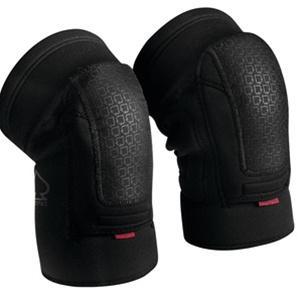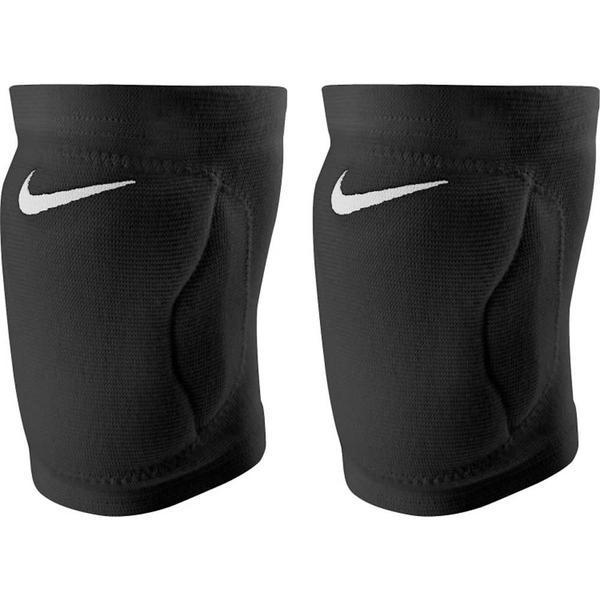The first image is the image on the left, the second image is the image on the right. Examine the images to the left and right. Is the description "Images each show one knee pad, and pads are turned facing the same direction." accurate? Answer yes or no. No. The first image is the image on the left, the second image is the image on the right. Analyze the images presented: Is the assertion "There are two black knee pads." valid? Answer yes or no. No. 